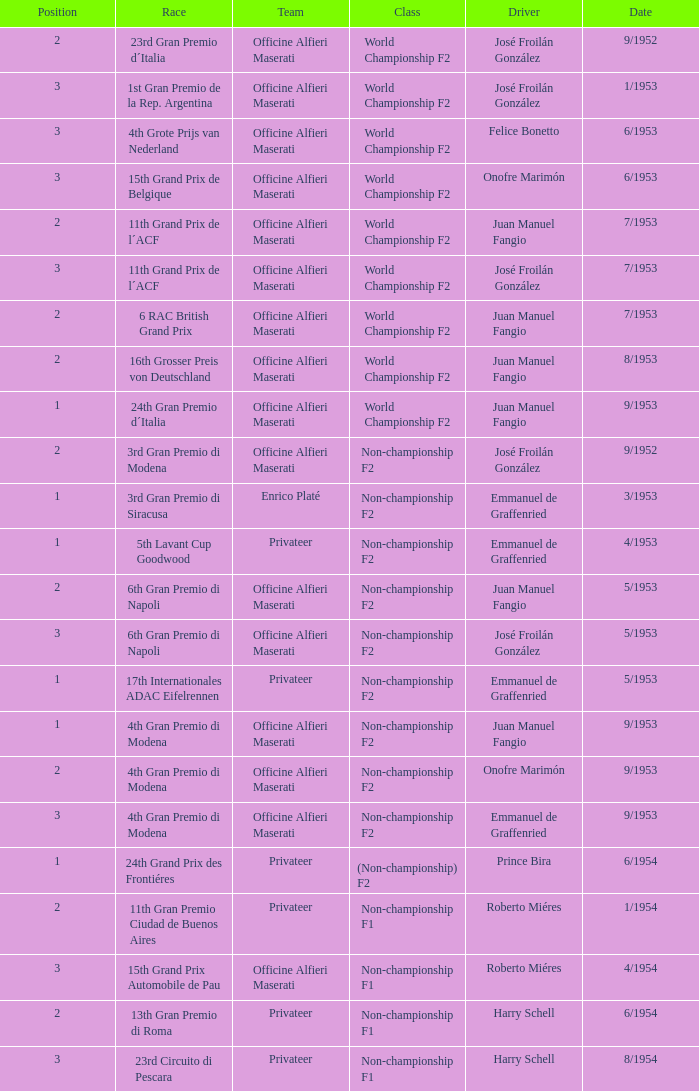What class has the date of 8/1954? Non-championship F1. 